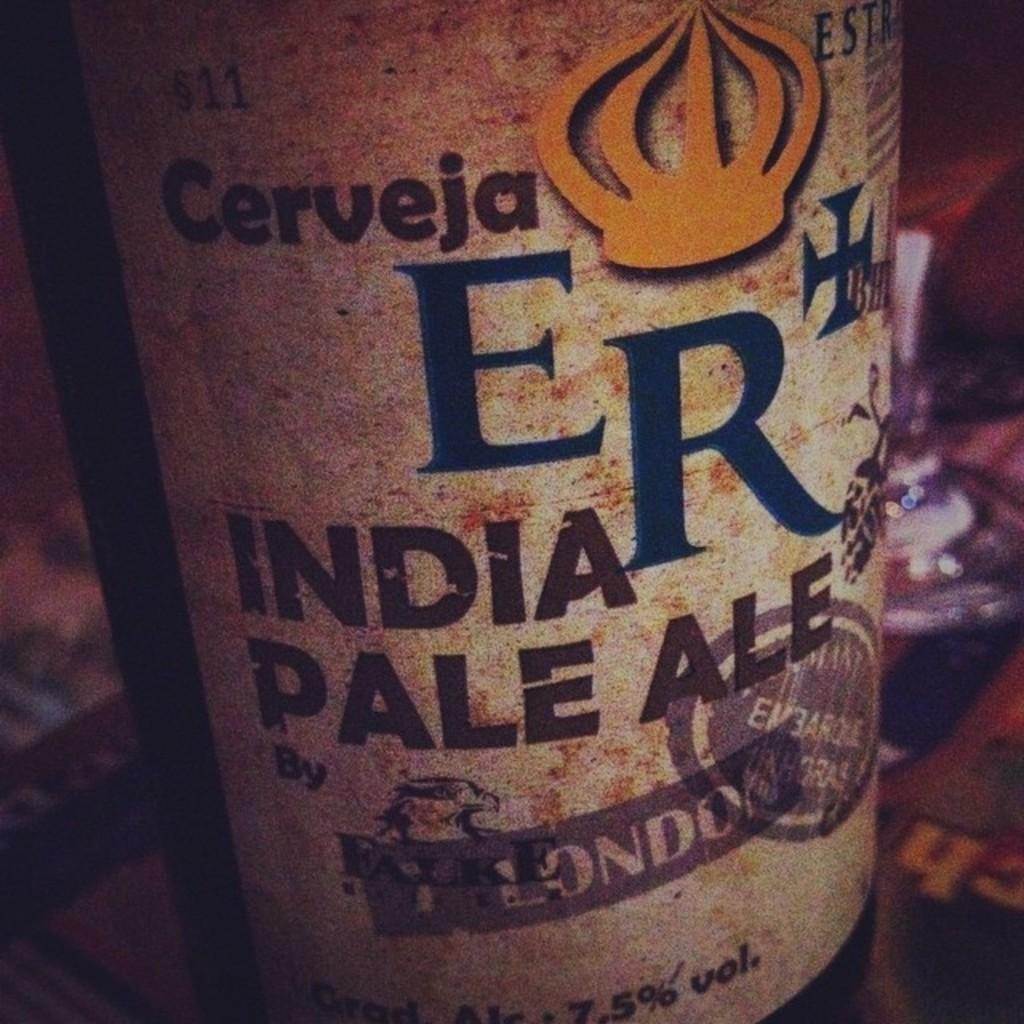What object can be seen in the image? There is a bottle in the image. What is featured on the bottle? There is text on the bottle. Can you describe the background of the image? The background of the image is blurred. What type of soap is being used to wash the beetle in the image? There is no soap or beetle present in the image; it only features a bottle with text on it. 